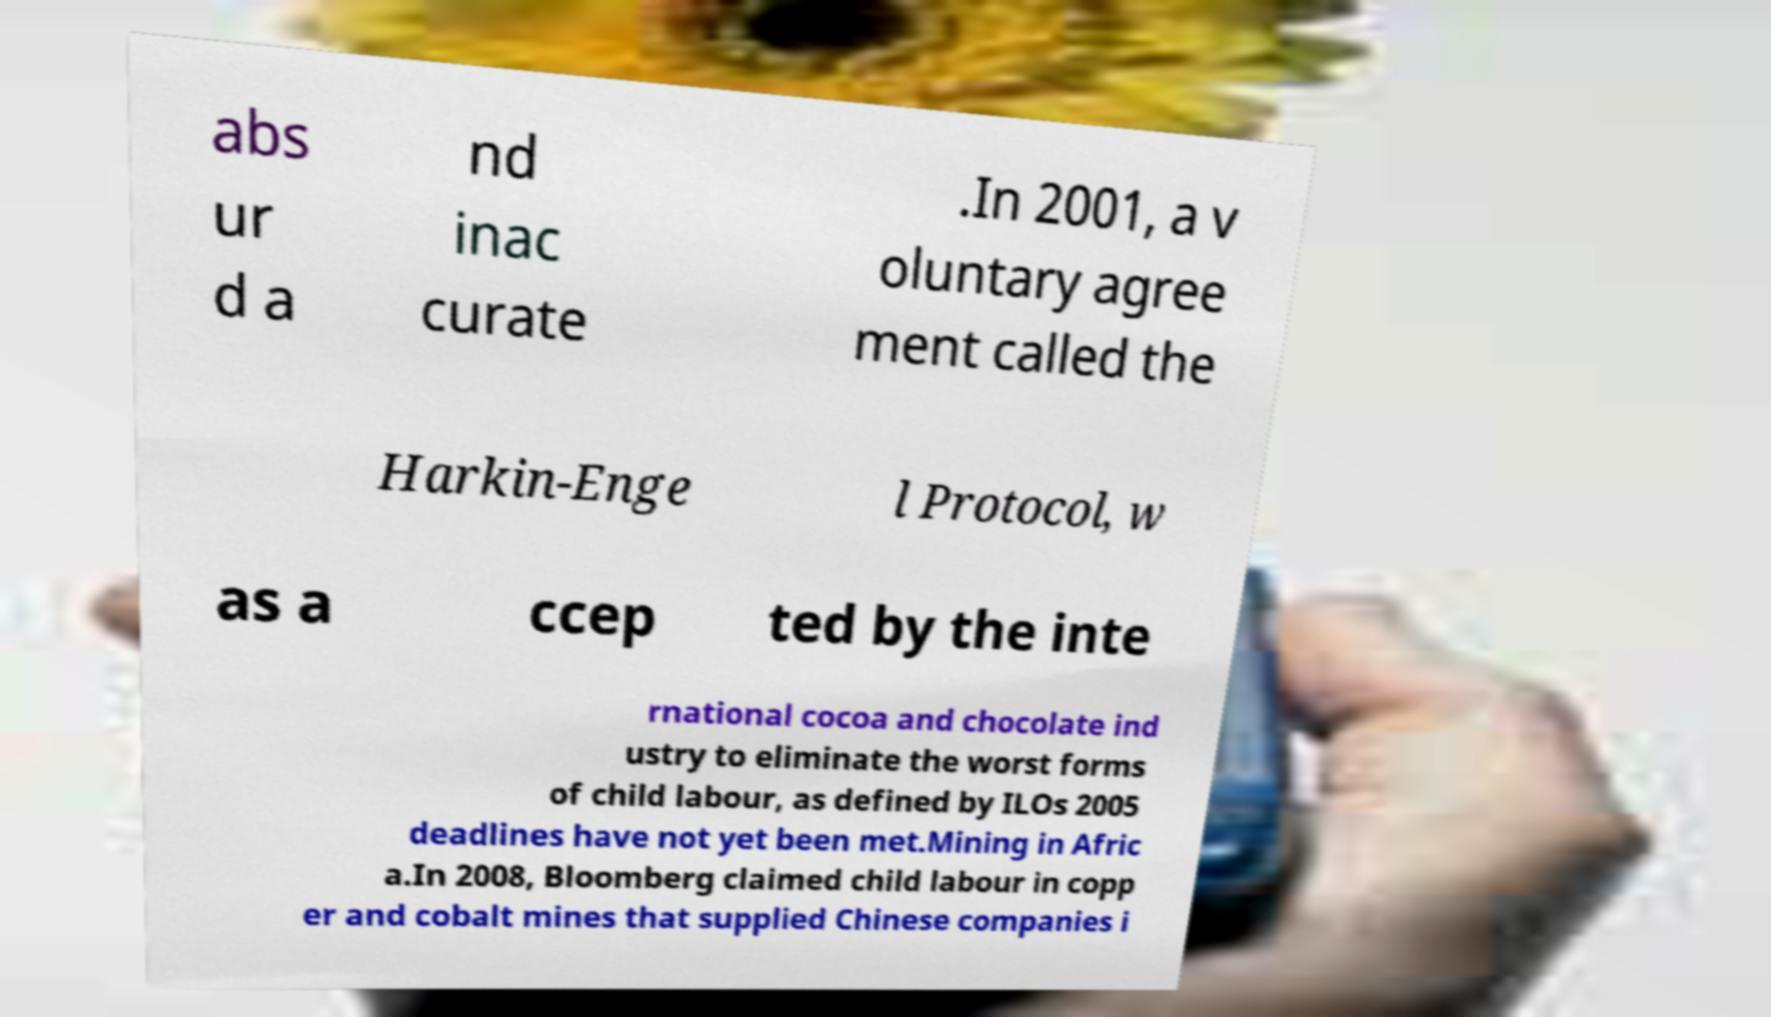There's text embedded in this image that I need extracted. Can you transcribe it verbatim? abs ur d a nd inac curate .In 2001, a v oluntary agree ment called the Harkin-Enge l Protocol, w as a ccep ted by the inte rnational cocoa and chocolate ind ustry to eliminate the worst forms of child labour, as defined by ILOs 2005 deadlines have not yet been met.Mining in Afric a.In 2008, Bloomberg claimed child labour in copp er and cobalt mines that supplied Chinese companies i 